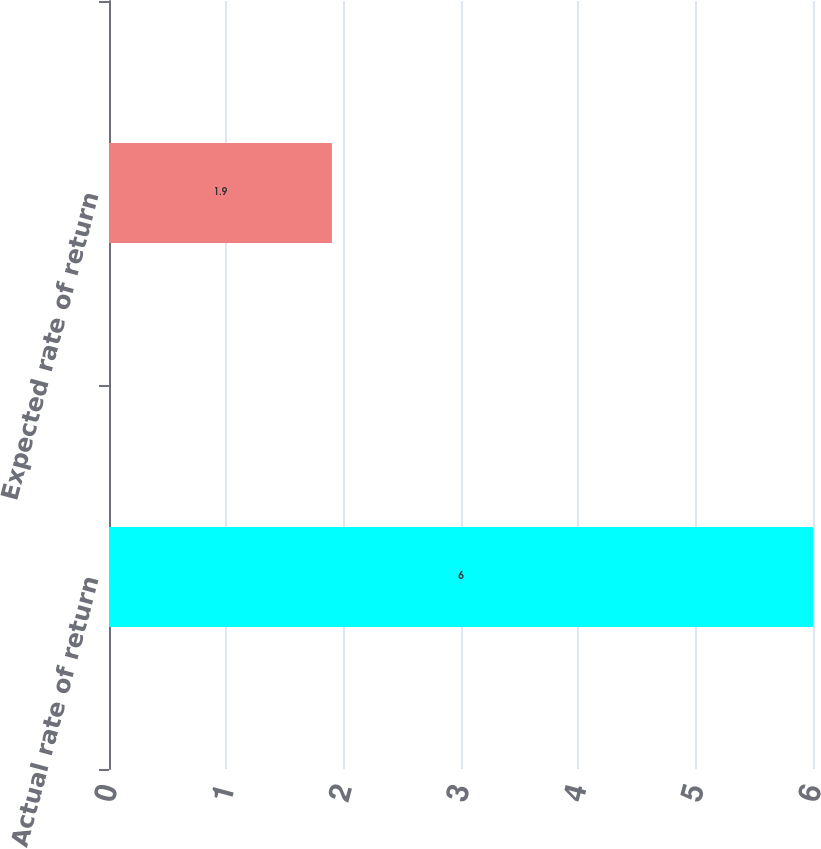Convert chart to OTSL. <chart><loc_0><loc_0><loc_500><loc_500><bar_chart><fcel>Actual rate of return<fcel>Expected rate of return<nl><fcel>6<fcel>1.9<nl></chart> 